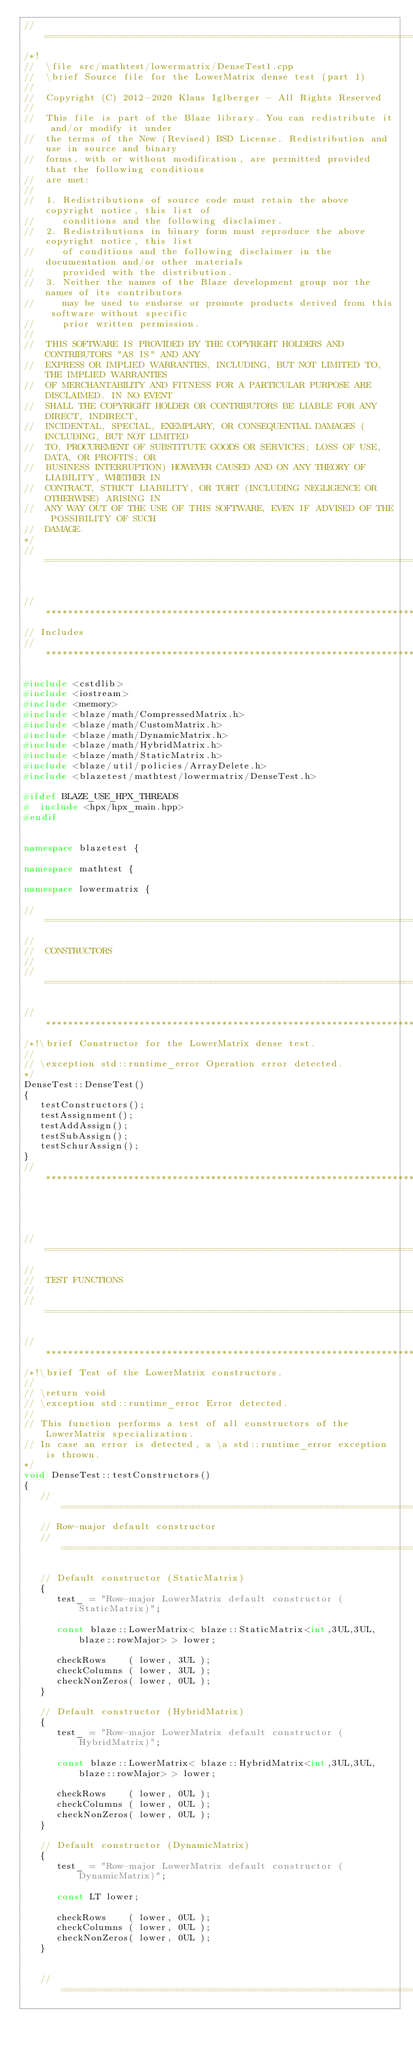Convert code to text. <code><loc_0><loc_0><loc_500><loc_500><_C++_>//=================================================================================================
/*!
//  \file src/mathtest/lowermatrix/DenseTest1.cpp
//  \brief Source file for the LowerMatrix dense test (part 1)
//
//  Copyright (C) 2012-2020 Klaus Iglberger - All Rights Reserved
//
//  This file is part of the Blaze library. You can redistribute it and/or modify it under
//  the terms of the New (Revised) BSD License. Redistribution and use in source and binary
//  forms, with or without modification, are permitted provided that the following conditions
//  are met:
//
//  1. Redistributions of source code must retain the above copyright notice, this list of
//     conditions and the following disclaimer.
//  2. Redistributions in binary form must reproduce the above copyright notice, this list
//     of conditions and the following disclaimer in the documentation and/or other materials
//     provided with the distribution.
//  3. Neither the names of the Blaze development group nor the names of its contributors
//     may be used to endorse or promote products derived from this software without specific
//     prior written permission.
//
//  THIS SOFTWARE IS PROVIDED BY THE COPYRIGHT HOLDERS AND CONTRIBUTORS "AS IS" AND ANY
//  EXPRESS OR IMPLIED WARRANTIES, INCLUDING, BUT NOT LIMITED TO, THE IMPLIED WARRANTIES
//  OF MERCHANTABILITY AND FITNESS FOR A PARTICULAR PURPOSE ARE DISCLAIMED. IN NO EVENT
//  SHALL THE COPYRIGHT HOLDER OR CONTRIBUTORS BE LIABLE FOR ANY DIRECT, INDIRECT,
//  INCIDENTAL, SPECIAL, EXEMPLARY, OR CONSEQUENTIAL DAMAGES (INCLUDING, BUT NOT LIMITED
//  TO, PROCUREMENT OF SUBSTITUTE GOODS OR SERVICES; LOSS OF USE, DATA, OR PROFITS; OR
//  BUSINESS INTERRUPTION) HOWEVER CAUSED AND ON ANY THEORY OF LIABILITY, WHETHER IN
//  CONTRACT, STRICT LIABILITY, OR TORT (INCLUDING NEGLIGENCE OR OTHERWISE) ARISING IN
//  ANY WAY OUT OF THE USE OF THIS SOFTWARE, EVEN IF ADVISED OF THE POSSIBILITY OF SUCH
//  DAMAGE.
*/
//=================================================================================================


//*************************************************************************************************
// Includes
//*************************************************************************************************

#include <cstdlib>
#include <iostream>
#include <memory>
#include <blaze/math/CompressedMatrix.h>
#include <blaze/math/CustomMatrix.h>
#include <blaze/math/DynamicMatrix.h>
#include <blaze/math/HybridMatrix.h>
#include <blaze/math/StaticMatrix.h>
#include <blaze/util/policies/ArrayDelete.h>
#include <blazetest/mathtest/lowermatrix/DenseTest.h>

#ifdef BLAZE_USE_HPX_THREADS
#  include <hpx/hpx_main.hpp>
#endif


namespace blazetest {

namespace mathtest {

namespace lowermatrix {

//=================================================================================================
//
//  CONSTRUCTORS
//
//=================================================================================================

//*************************************************************************************************
/*!\brief Constructor for the LowerMatrix dense test.
//
// \exception std::runtime_error Operation error detected.
*/
DenseTest::DenseTest()
{
   testConstructors();
   testAssignment();
   testAddAssign();
   testSubAssign();
   testSchurAssign();
}
//*************************************************************************************************




//=================================================================================================
//
//  TEST FUNCTIONS
//
//=================================================================================================

//*************************************************************************************************
/*!\brief Test of the LowerMatrix constructors.
//
// \return void
// \exception std::runtime_error Error detected.
//
// This function performs a test of all constructors of the LowerMatrix specialization.
// In case an error is detected, a \a std::runtime_error exception is thrown.
*/
void DenseTest::testConstructors()
{
   //=====================================================================================
   // Row-major default constructor
   //=====================================================================================

   // Default constructor (StaticMatrix)
   {
      test_ = "Row-major LowerMatrix default constructor (StaticMatrix)";

      const blaze::LowerMatrix< blaze::StaticMatrix<int,3UL,3UL,blaze::rowMajor> > lower;

      checkRows    ( lower, 3UL );
      checkColumns ( lower, 3UL );
      checkNonZeros( lower, 0UL );
   }

   // Default constructor (HybridMatrix)
   {
      test_ = "Row-major LowerMatrix default constructor (HybridMatrix)";

      const blaze::LowerMatrix< blaze::HybridMatrix<int,3UL,3UL,blaze::rowMajor> > lower;

      checkRows    ( lower, 0UL );
      checkColumns ( lower, 0UL );
      checkNonZeros( lower, 0UL );
   }

   // Default constructor (DynamicMatrix)
   {
      test_ = "Row-major LowerMatrix default constructor (DynamicMatrix)";

      const LT lower;

      checkRows    ( lower, 0UL );
      checkColumns ( lower, 0UL );
      checkNonZeros( lower, 0UL );
   }


   //=====================================================================================</code> 